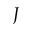Convert formula to latex. <formula><loc_0><loc_0><loc_500><loc_500>J</formula> 